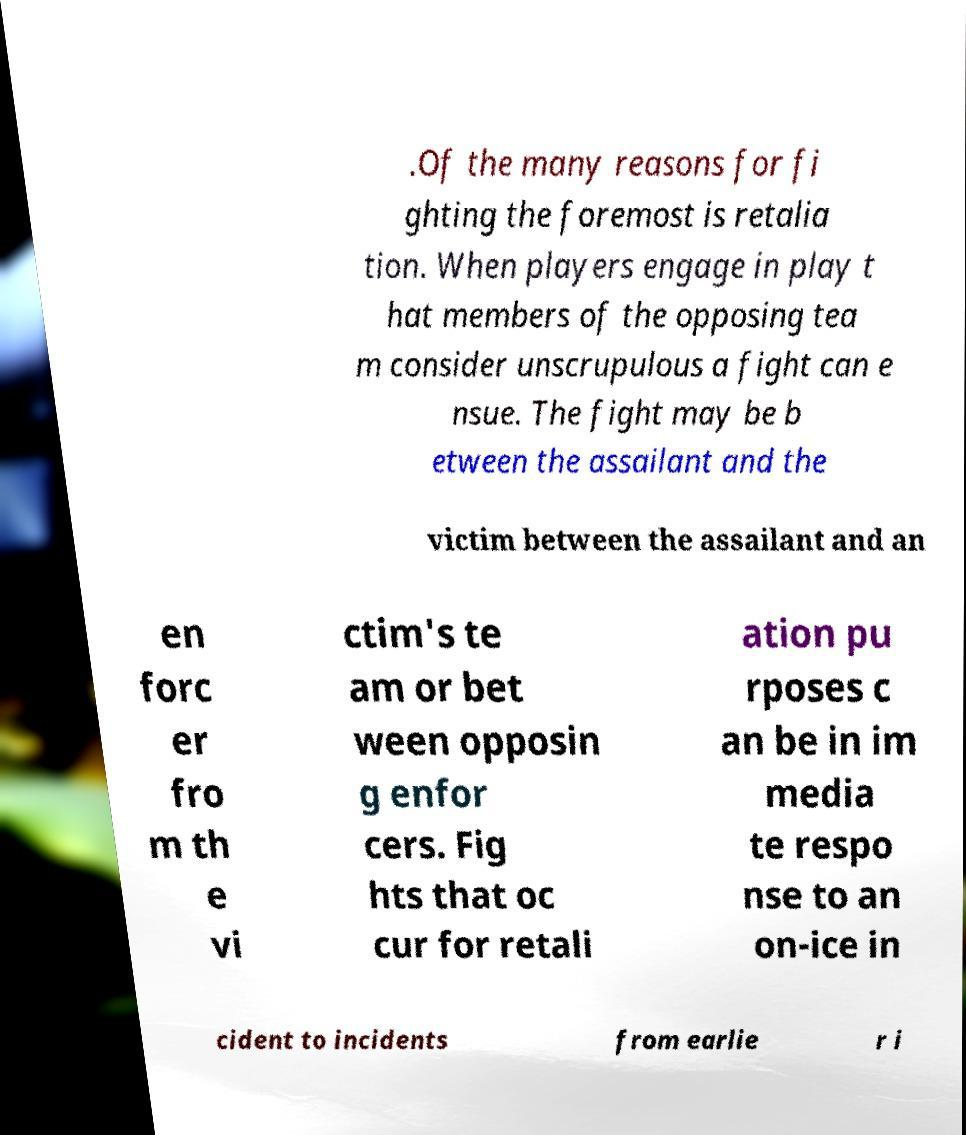There's text embedded in this image that I need extracted. Can you transcribe it verbatim? .Of the many reasons for fi ghting the foremost is retalia tion. When players engage in play t hat members of the opposing tea m consider unscrupulous a fight can e nsue. The fight may be b etween the assailant and the victim between the assailant and an en forc er fro m th e vi ctim's te am or bet ween opposin g enfor cers. Fig hts that oc cur for retali ation pu rposes c an be in im media te respo nse to an on-ice in cident to incidents from earlie r i 